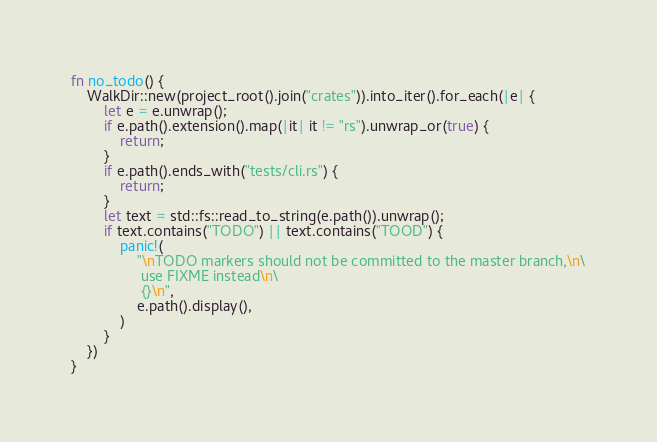Convert code to text. <code><loc_0><loc_0><loc_500><loc_500><_Rust_>fn no_todo() {
    WalkDir::new(project_root().join("crates")).into_iter().for_each(|e| {
        let e = e.unwrap();
        if e.path().extension().map(|it| it != "rs").unwrap_or(true) {
            return;
        }
        if e.path().ends_with("tests/cli.rs") {
            return;
        }
        let text = std::fs::read_to_string(e.path()).unwrap();
        if text.contains("TODO") || text.contains("TOOD") {
            panic!(
                "\nTODO markers should not be committed to the master branch,\n\
                 use FIXME instead\n\
                 {}\n",
                e.path().display(),
            )
        }
    })
}
</code> 